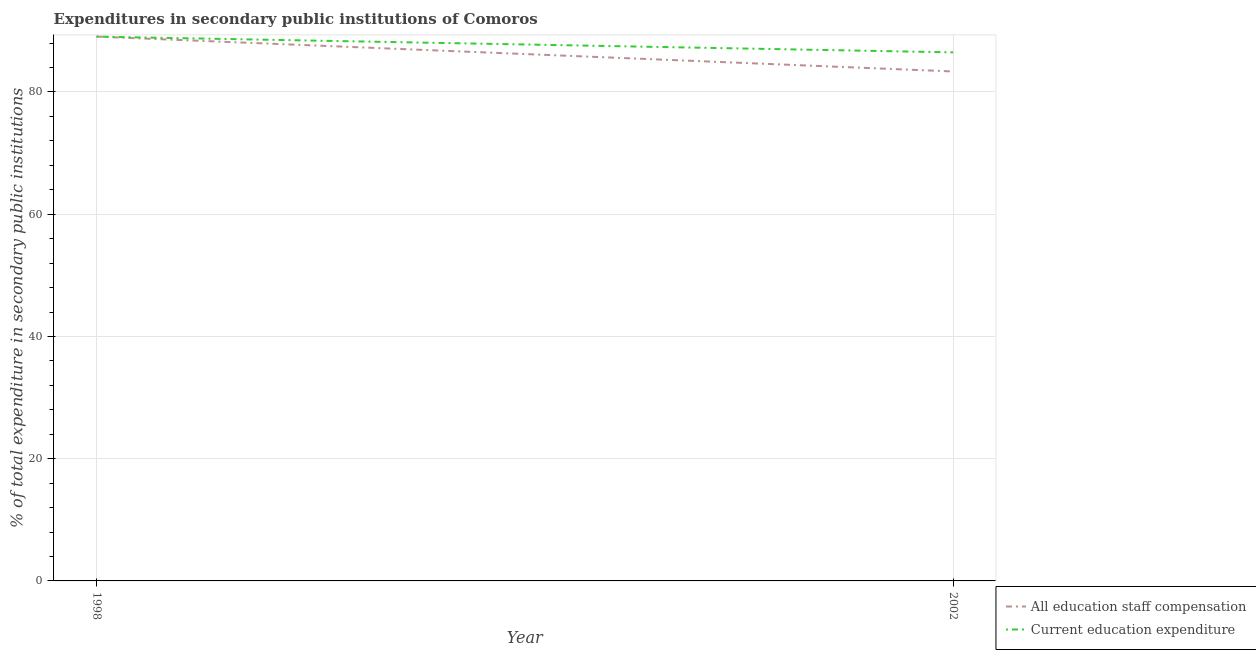How many different coloured lines are there?
Offer a terse response. 2. Does the line corresponding to expenditure in staff compensation intersect with the line corresponding to expenditure in education?
Provide a short and direct response. Yes. Is the number of lines equal to the number of legend labels?
Your response must be concise. Yes. What is the expenditure in staff compensation in 2002?
Make the answer very short. 83.36. Across all years, what is the maximum expenditure in education?
Offer a very short reply. 89.06. Across all years, what is the minimum expenditure in education?
Keep it short and to the point. 86.48. In which year was the expenditure in staff compensation maximum?
Provide a succinct answer. 1998. In which year was the expenditure in staff compensation minimum?
Your response must be concise. 2002. What is the total expenditure in staff compensation in the graph?
Your answer should be very brief. 172.42. What is the difference between the expenditure in staff compensation in 1998 and that in 2002?
Offer a very short reply. 5.7. What is the difference between the expenditure in education in 2002 and the expenditure in staff compensation in 1998?
Provide a short and direct response. -2.58. What is the average expenditure in staff compensation per year?
Make the answer very short. 86.21. In how many years, is the expenditure in staff compensation greater than 12 %?
Your answer should be very brief. 2. What is the ratio of the expenditure in education in 1998 to that in 2002?
Keep it short and to the point. 1.03. In how many years, is the expenditure in education greater than the average expenditure in education taken over all years?
Your answer should be compact. 1. Is the expenditure in staff compensation strictly greater than the expenditure in education over the years?
Offer a terse response. No. How many years are there in the graph?
Your answer should be very brief. 2. What is the difference between two consecutive major ticks on the Y-axis?
Give a very brief answer. 20. Are the values on the major ticks of Y-axis written in scientific E-notation?
Offer a terse response. No. Does the graph contain any zero values?
Ensure brevity in your answer.  No. Does the graph contain grids?
Your answer should be very brief. Yes. Where does the legend appear in the graph?
Offer a very short reply. Bottom right. How many legend labels are there?
Your response must be concise. 2. How are the legend labels stacked?
Your response must be concise. Vertical. What is the title of the graph?
Offer a terse response. Expenditures in secondary public institutions of Comoros. Does "2012 US$" appear as one of the legend labels in the graph?
Provide a short and direct response. No. What is the label or title of the Y-axis?
Offer a very short reply. % of total expenditure in secondary public institutions. What is the % of total expenditure in secondary public institutions of All education staff compensation in 1998?
Make the answer very short. 89.06. What is the % of total expenditure in secondary public institutions in Current education expenditure in 1998?
Offer a very short reply. 89.06. What is the % of total expenditure in secondary public institutions of All education staff compensation in 2002?
Make the answer very short. 83.36. What is the % of total expenditure in secondary public institutions of Current education expenditure in 2002?
Make the answer very short. 86.48. Across all years, what is the maximum % of total expenditure in secondary public institutions of All education staff compensation?
Give a very brief answer. 89.06. Across all years, what is the maximum % of total expenditure in secondary public institutions of Current education expenditure?
Provide a succinct answer. 89.06. Across all years, what is the minimum % of total expenditure in secondary public institutions of All education staff compensation?
Keep it short and to the point. 83.36. Across all years, what is the minimum % of total expenditure in secondary public institutions of Current education expenditure?
Provide a succinct answer. 86.48. What is the total % of total expenditure in secondary public institutions in All education staff compensation in the graph?
Keep it short and to the point. 172.42. What is the total % of total expenditure in secondary public institutions of Current education expenditure in the graph?
Keep it short and to the point. 175.54. What is the difference between the % of total expenditure in secondary public institutions in All education staff compensation in 1998 and that in 2002?
Your answer should be very brief. 5.7. What is the difference between the % of total expenditure in secondary public institutions of Current education expenditure in 1998 and that in 2002?
Make the answer very short. 2.58. What is the difference between the % of total expenditure in secondary public institutions in All education staff compensation in 1998 and the % of total expenditure in secondary public institutions in Current education expenditure in 2002?
Make the answer very short. 2.58. What is the average % of total expenditure in secondary public institutions in All education staff compensation per year?
Keep it short and to the point. 86.21. What is the average % of total expenditure in secondary public institutions of Current education expenditure per year?
Offer a terse response. 87.77. In the year 1998, what is the difference between the % of total expenditure in secondary public institutions of All education staff compensation and % of total expenditure in secondary public institutions of Current education expenditure?
Your response must be concise. 0. In the year 2002, what is the difference between the % of total expenditure in secondary public institutions in All education staff compensation and % of total expenditure in secondary public institutions in Current education expenditure?
Your answer should be compact. -3.13. What is the ratio of the % of total expenditure in secondary public institutions of All education staff compensation in 1998 to that in 2002?
Keep it short and to the point. 1.07. What is the ratio of the % of total expenditure in secondary public institutions in Current education expenditure in 1998 to that in 2002?
Keep it short and to the point. 1.03. What is the difference between the highest and the second highest % of total expenditure in secondary public institutions of All education staff compensation?
Your answer should be compact. 5.7. What is the difference between the highest and the second highest % of total expenditure in secondary public institutions in Current education expenditure?
Ensure brevity in your answer.  2.58. What is the difference between the highest and the lowest % of total expenditure in secondary public institutions of All education staff compensation?
Keep it short and to the point. 5.7. What is the difference between the highest and the lowest % of total expenditure in secondary public institutions in Current education expenditure?
Offer a very short reply. 2.58. 